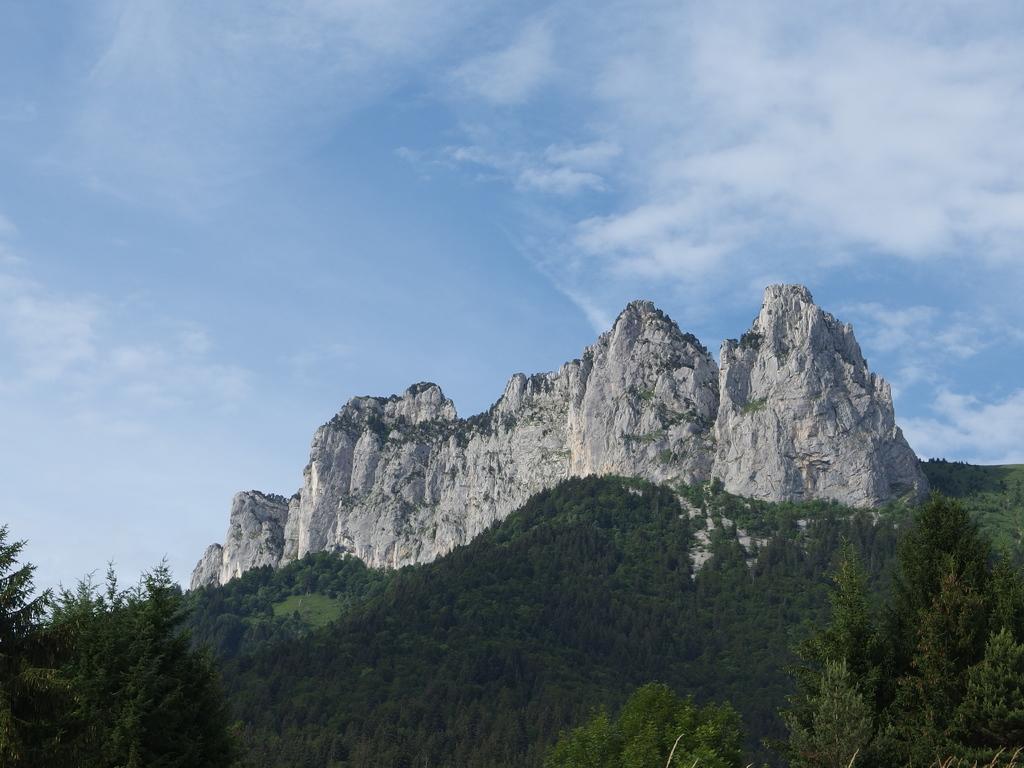Could you give a brief overview of what you see in this image? In this picture we can see trees, mountains and in the background we can see the sky with clouds. 